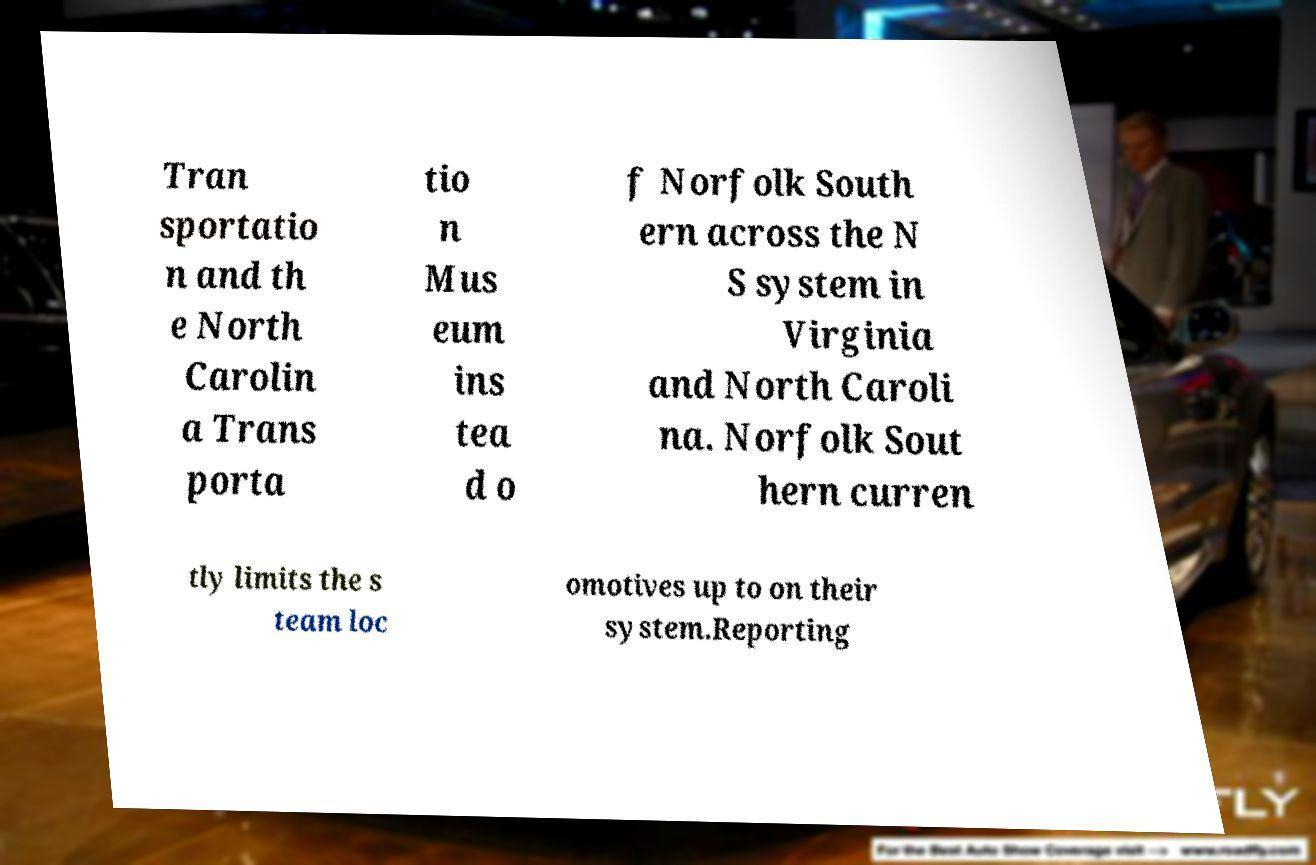Please identify and transcribe the text found in this image. Tran sportatio n and th e North Carolin a Trans porta tio n Mus eum ins tea d o f Norfolk South ern across the N S system in Virginia and North Caroli na. Norfolk Sout hern curren tly limits the s team loc omotives up to on their system.Reporting 